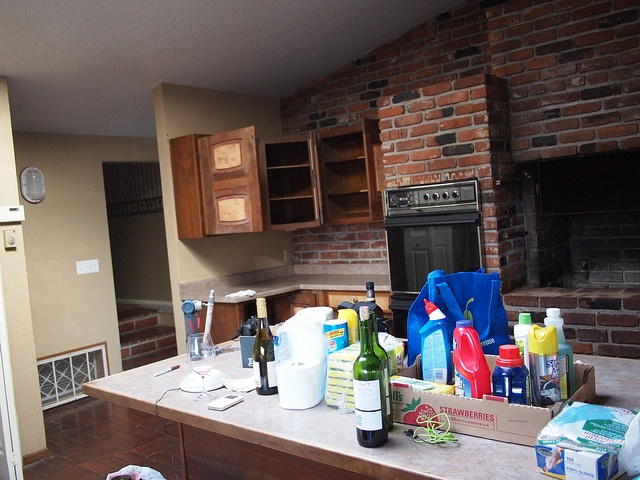Describe the objects in this image and their specific colors. I can see oven in gray, black, and darkgray tones, bottle in gray, white, black, darkgreen, and teal tones, bottle in gray, red, brown, and salmon tones, bottle in gray, lightblue, white, and blue tones, and bottle in gray, navy, red, black, and darkblue tones in this image. 